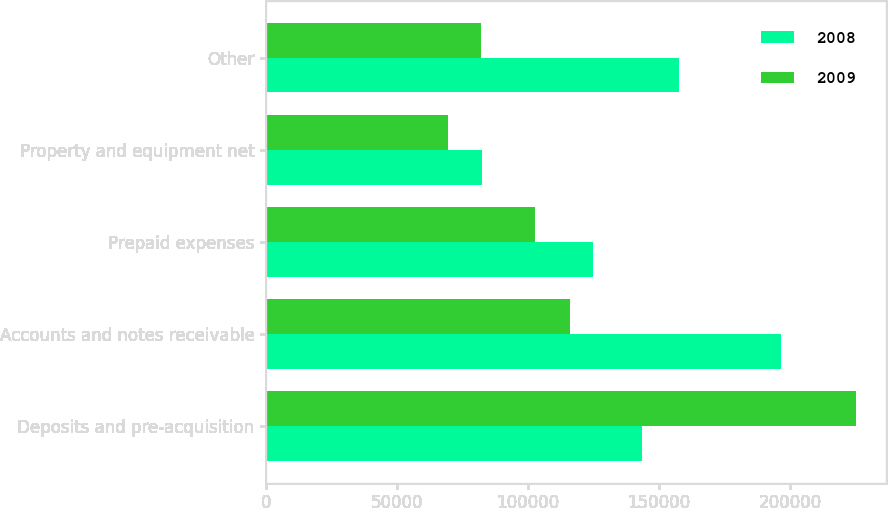Convert chart. <chart><loc_0><loc_0><loc_500><loc_500><stacked_bar_chart><ecel><fcel>Deposits and pre-acquisition<fcel>Accounts and notes receivable<fcel>Prepaid expenses<fcel>Property and equipment net<fcel>Other<nl><fcel>2008<fcel>143502<fcel>196622<fcel>124790<fcel>82419<fcel>157707<nl><fcel>2009<fcel>225292<fcel>115918<fcel>102737<fcel>69297<fcel>81854<nl></chart> 